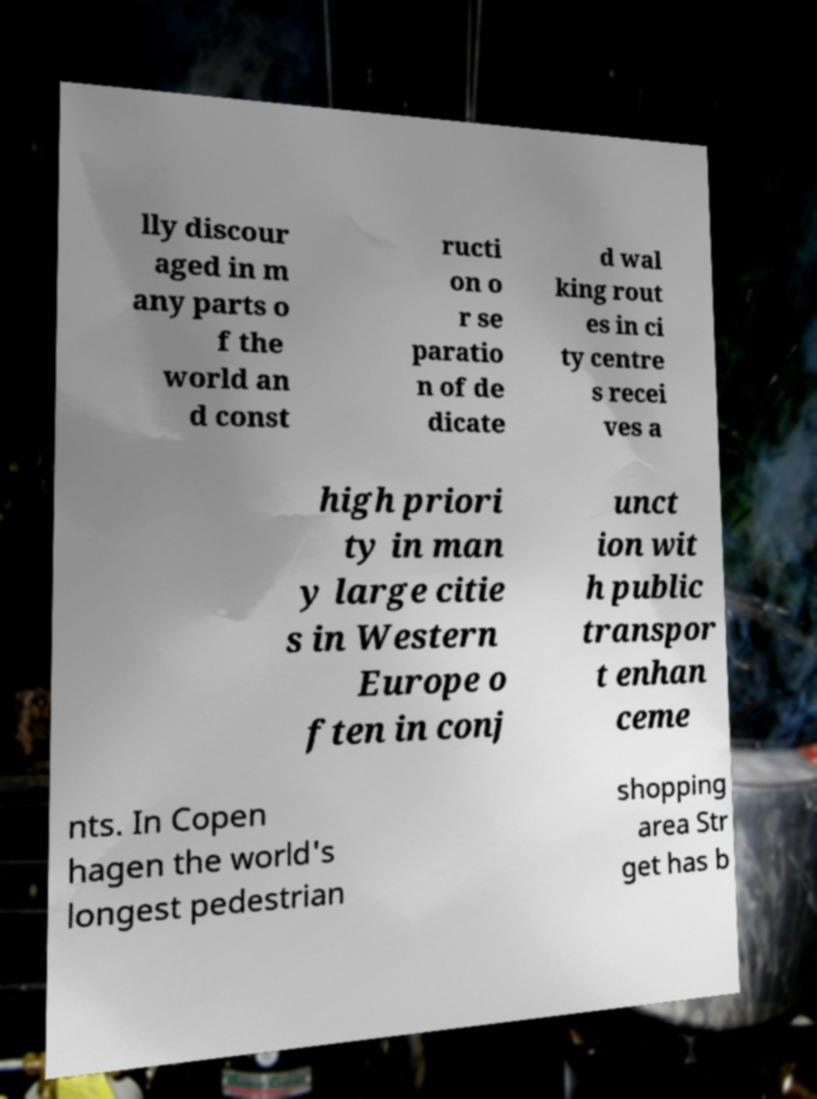For documentation purposes, I need the text within this image transcribed. Could you provide that? lly discour aged in m any parts o f the world an d const ructi on o r se paratio n of de dicate d wal king rout es in ci ty centre s recei ves a high priori ty in man y large citie s in Western Europe o ften in conj unct ion wit h public transpor t enhan ceme nts. In Copen hagen the world's longest pedestrian shopping area Str get has b 